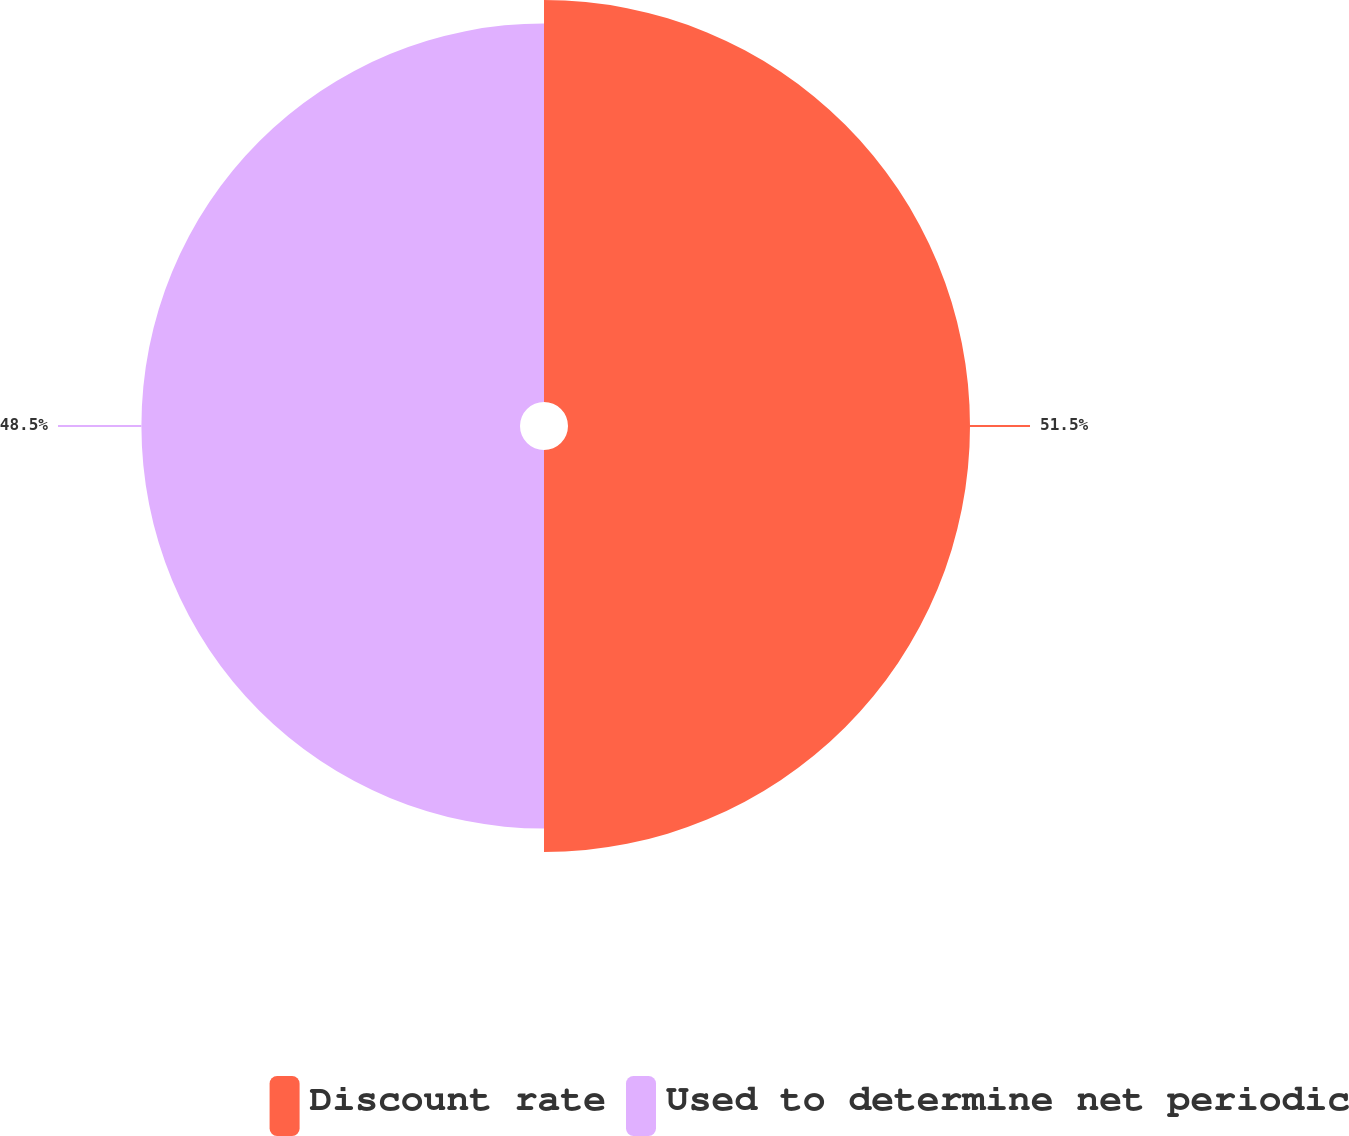<chart> <loc_0><loc_0><loc_500><loc_500><pie_chart><fcel>Discount rate<fcel>Used to determine net periodic<nl><fcel>51.5%<fcel>48.5%<nl></chart> 